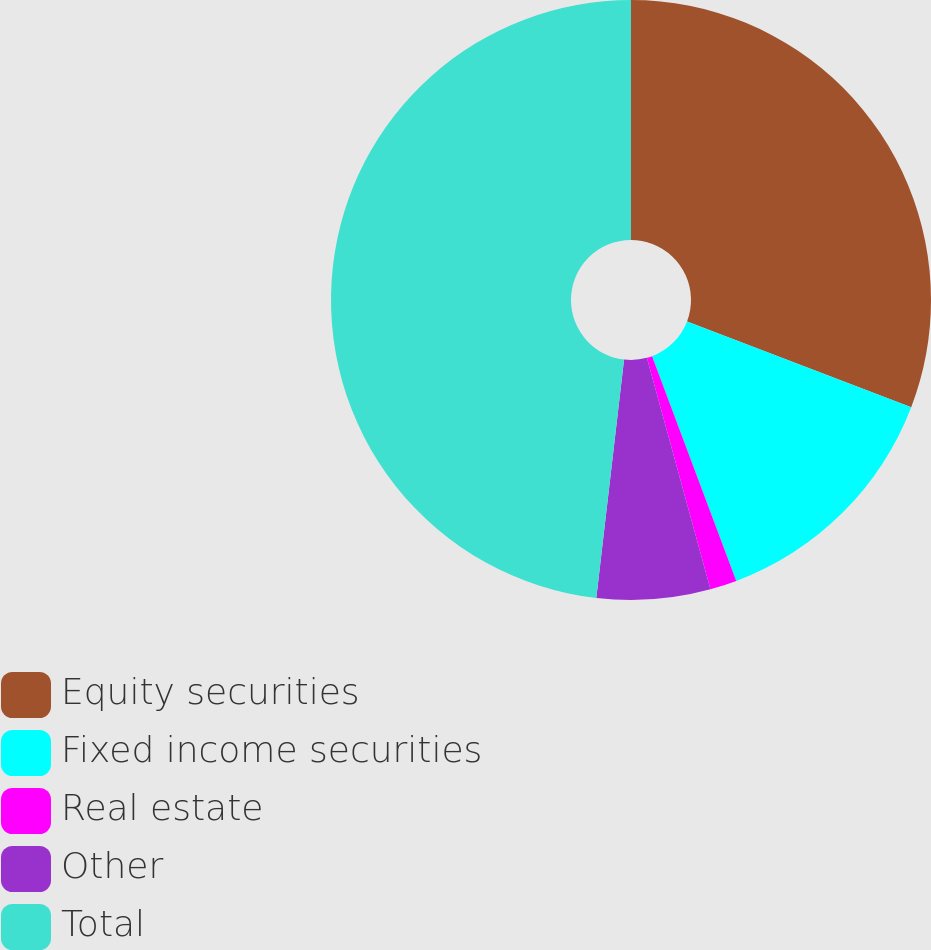<chart> <loc_0><loc_0><loc_500><loc_500><pie_chart><fcel>Equity securities<fcel>Fixed income securities<fcel>Real estate<fcel>Other<fcel>Total<nl><fcel>30.81%<fcel>13.48%<fcel>1.44%<fcel>6.11%<fcel>48.15%<nl></chart> 